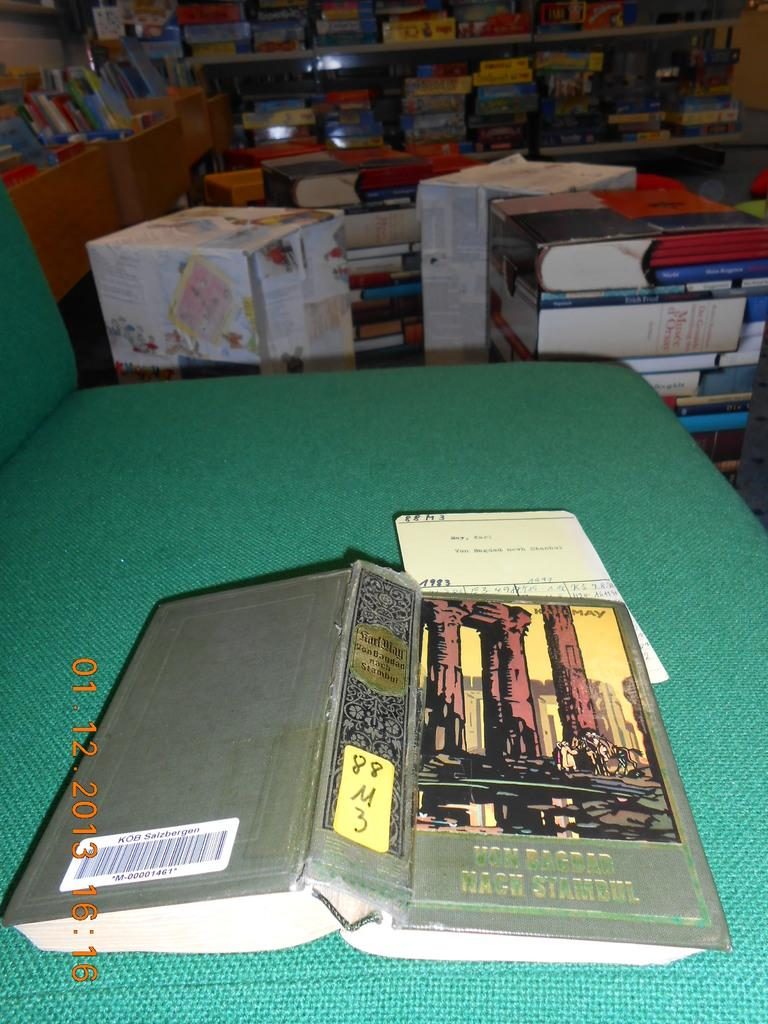Provide a one-sentence caption for the provided image. A book open in the middle laying face down on a table with the title VON BAGBAD WACH STAMBUL. 